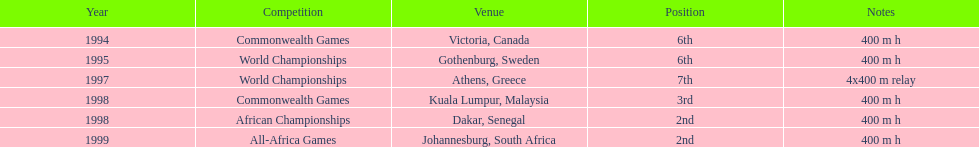In which year, apart from 1999, did ken harnden achieve a runner-up finish? 1998. 